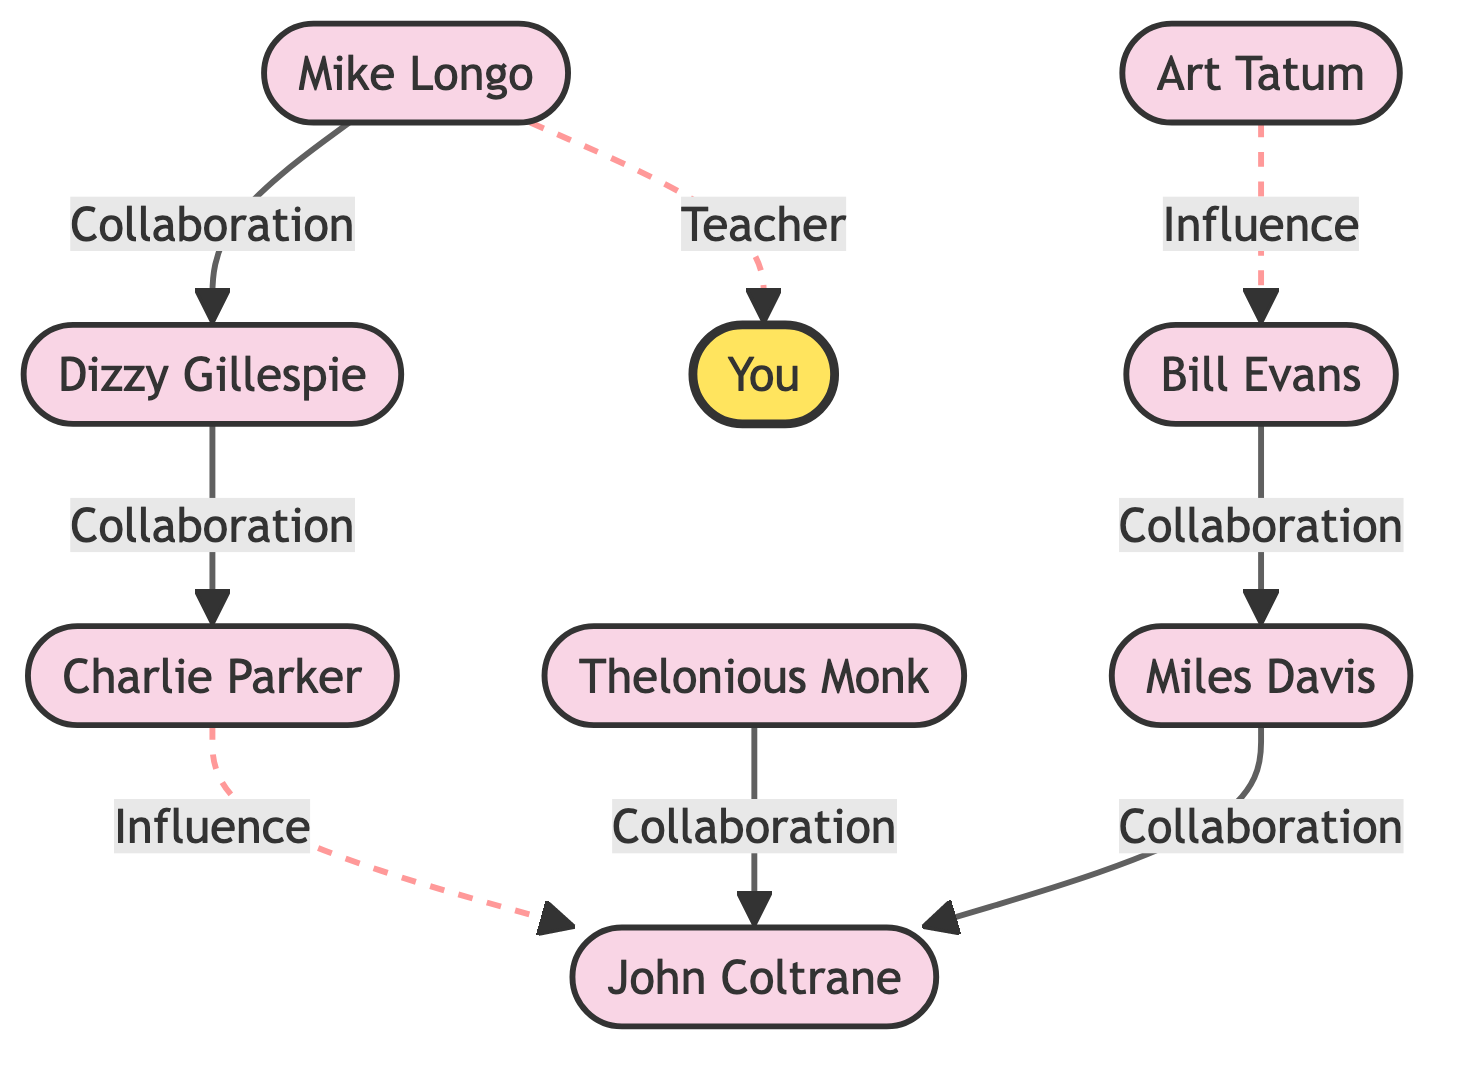What is the total number of musicians in the diagram? There are nine nodes in the diagram that represent musicians. These include Dizzy Gillespie, Mike Longo, Charlie Parker, Thelonious Monk, John Coltrane, Miles Davis, Art Tatum, Bill Evans, and Yourself.
Answer: 9 Who collaborated with Dizzy Gillespie? The edge connecting Dizzy Gillespie to another node labeled "Mike Longo" shows a "Collaboration" relationship, indicating that Mike Longo collaborated with Dizzy Gillespie.
Answer: Mike Longo Which musician influenced John Coltrane? The diagram shows a dashed line from Charlie Parker to John Coltrane labeled "Influence." This indicates that Charlie Parker influenced John Coltrane.
Answer: Charlie Parker How many collaborations are associated with John Coltrane? The diagram indicates there are three edges directly connected to John Coltrane involving collaboration. These collaborations are with Thelonious Monk, Miles Davis, and the influence from Charlie Parker counts as one.
Answer: 3 Who is yourself connected to, and what type of relationship is shown? According to the diagram, Yourself is connected to Mike Longo with a dashed line labeled "Teacher," indicating a teacher-student relationship.
Answer: Mike Longo, Teacher Which musician is influenced by Art Tatum? The diagram shows that Art Tatum has an influence relationship with Bill Evans, indicated by a dashed line connecting the two with the label "Influence."
Answer: Bill Evans What type of relationships are symbolized by the dashed lines in the diagram? The dashed lines in the diagram represent influence or teacher-student relationships, distinguishing these connections from the solid lines that indicate collaboration.
Answer: Influence Which musician has the most direct collaborations? John Coltrane has the most direct collaborations, evident from solid lines connecting him to both Thelonious Monk and Miles Davis.
Answer: John Coltrane Is there a direct collaboration between Bill Evans and Dizzy Gillespie? There is no direct edge or line connecting Bill Evans to Dizzy Gillespie in the diagram, indicating that they do not have a direct collaboration.
Answer: No 